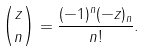Convert formula to latex. <formula><loc_0><loc_0><loc_500><loc_500>\binom { z } { n } = \frac { ( - 1 ) ^ { n } ( - z ) _ { n } } { n ! } .</formula> 